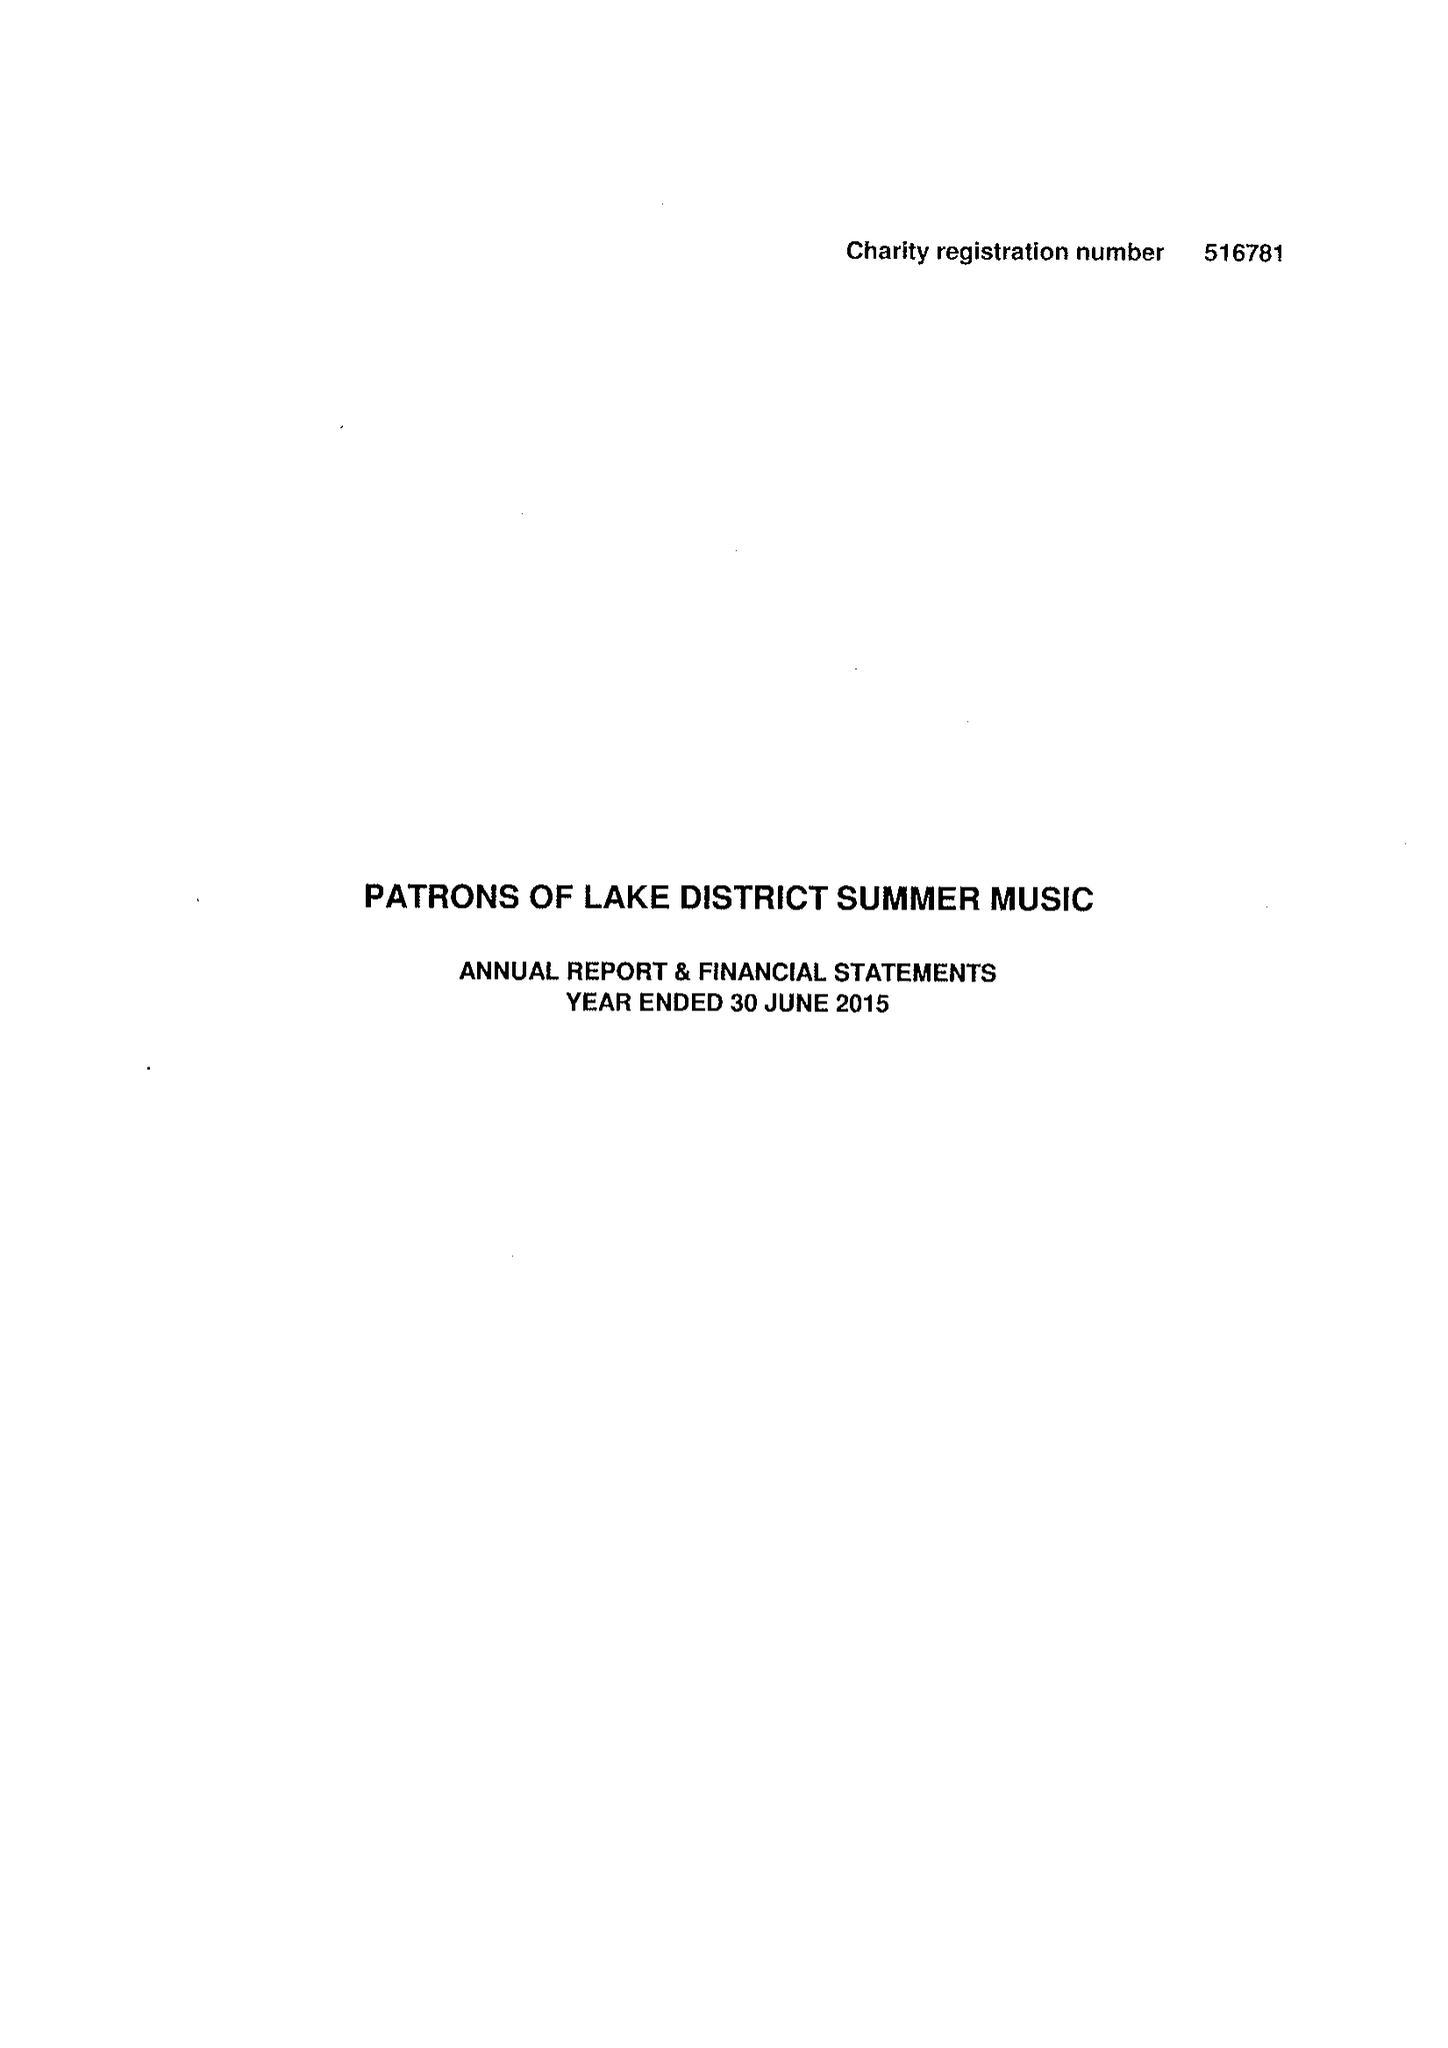What is the value for the address__post_town?
Answer the question using a single word or phrase. KENDAL 